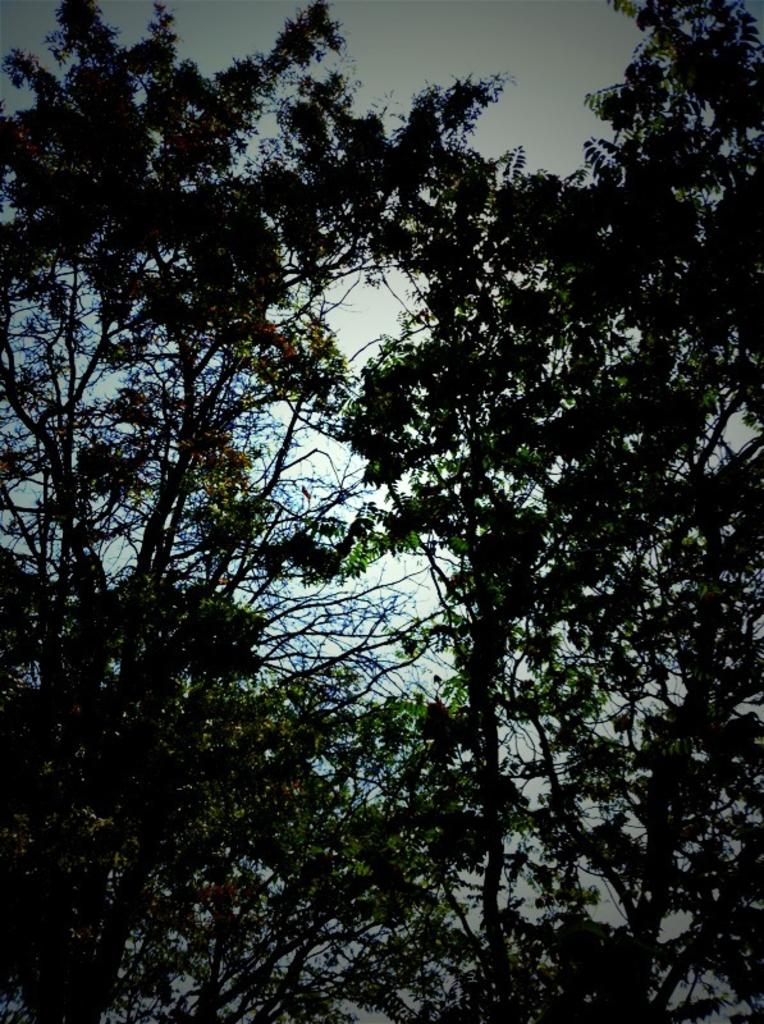What is located in the center of the image? There are trees in the center of the image. What can be seen in the background of the image? The sky is visible in the background of the image. How many bikes are leaning against the trees in the image? There are no bikes present in the image; it only features trees and the sky. What type of crate can be seen on the ground near the trees? There is no crate present in the image; it only features trees and the sky. 